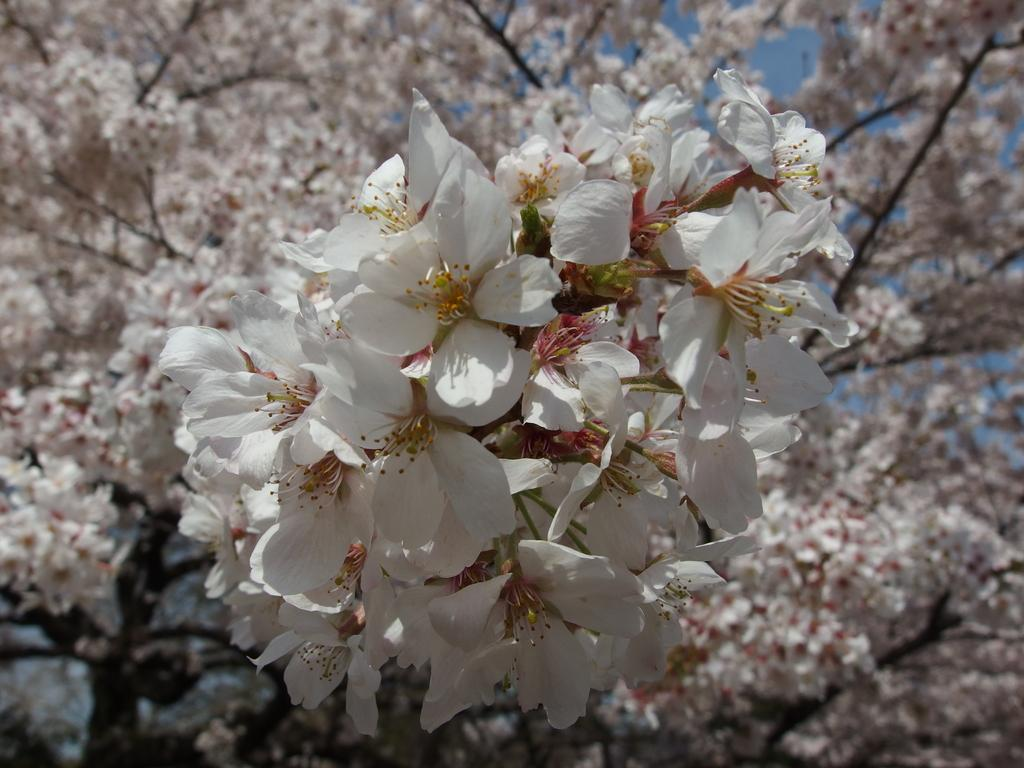What type of flowers can be seen in the image? There are white color flowers in the image. What other natural elements are present in the image? There are trees in the image. What direction are the trucks heading in the image? There are no trucks present in the image. What type of crop is growing near the corn in the image? There is no corn present in the image. 